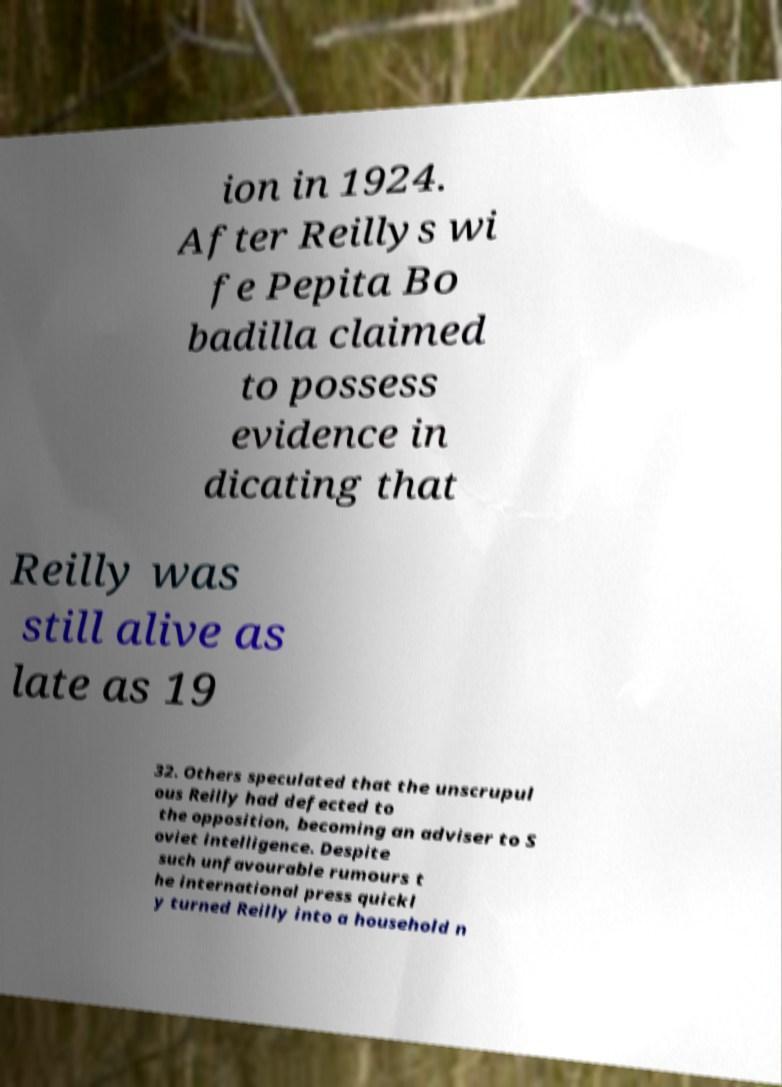For documentation purposes, I need the text within this image transcribed. Could you provide that? ion in 1924. After Reillys wi fe Pepita Bo badilla claimed to possess evidence in dicating that Reilly was still alive as late as 19 32. Others speculated that the unscrupul ous Reilly had defected to the opposition, becoming an adviser to S oviet intelligence. Despite such unfavourable rumours t he international press quickl y turned Reilly into a household n 